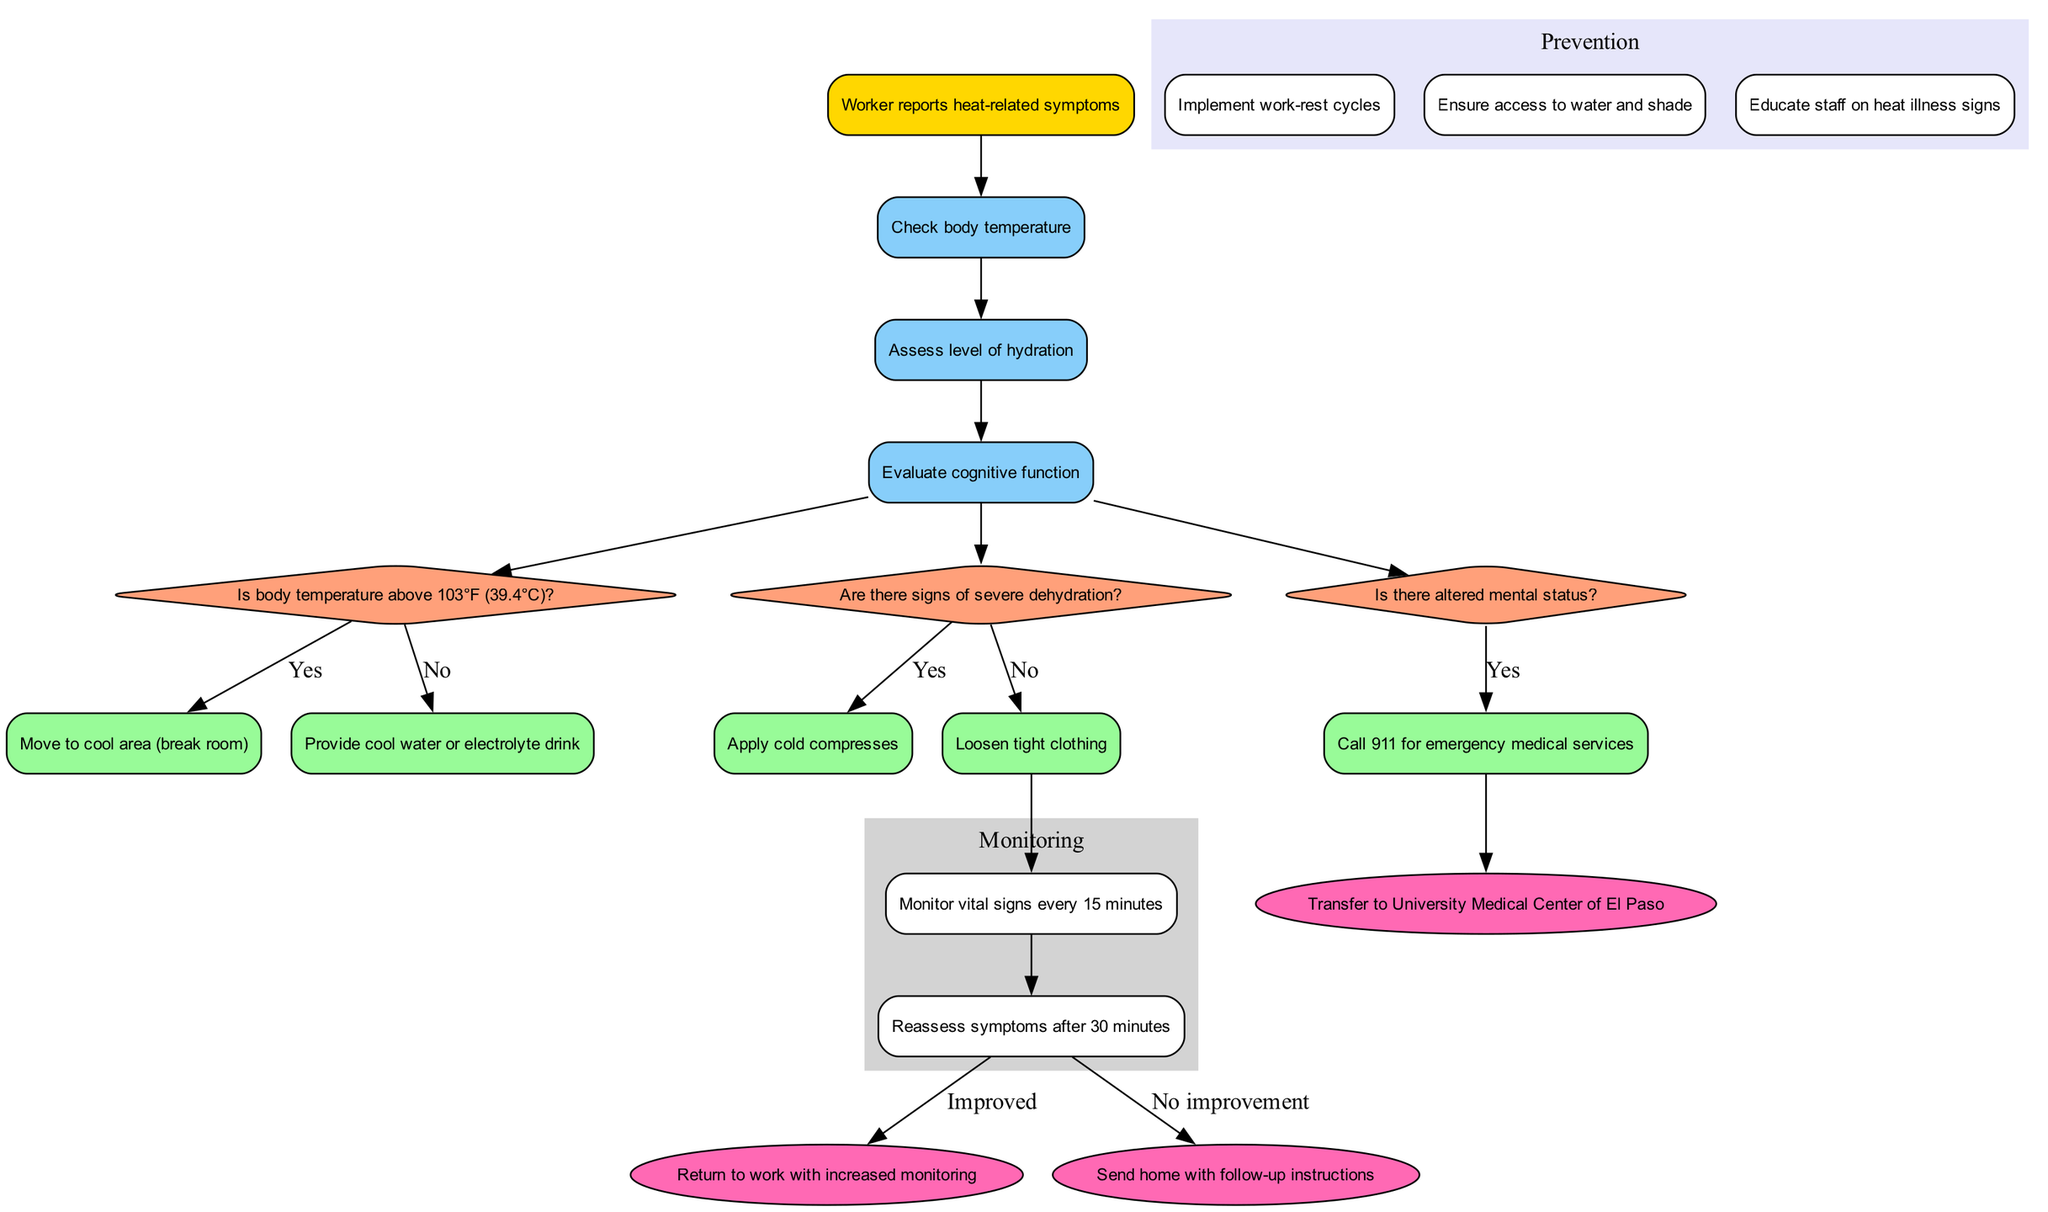What is the starting point of the clinical pathway? The starting point is indicated in the diagram as "Worker reports heat-related symptoms." This is the first node from which all assessment and decision-making steps are derived.
Answer: Worker reports heat-related symptoms How many assessment nodes are there? The diagram lists three assessment nodes: "Check body temperature," "Assess level of hydration," and "Evaluate cognitive function." Therefore, the total count can be directly gathered from this segment of the diagram.
Answer: 3 What action is taken if there are signs of severe dehydration? According to the diagram, if there are signs of severe dehydration, the action taken is to "Provide cool water or electrolyte drink." This action directly follows the relevant decision point regarding dehydration.
Answer: Provide cool water or electrolyte drink What happens if the body temperature is above 103°F? The diagram indicates that if the body temperature is above 103°F, the action is to "Move to cool area (break room)." This response is clearly linked to the corresponding decision point about body temperature.
Answer: Move to cool area (break room) What are the endpoints of the clinical pathway? The diagram outlines three endpoints, categorized as outcomes of the pathway: "Return to work with increased monitoring," "Send home with follow-up instructions," and "Transfer to University Medical Center of El Paso." This information can be found in the final section of the diagram.
Answer: Return to work with increased monitoring, Send home with follow-up instructions, Transfer to University Medical Center of El Paso If altered mental status is present, what is the next action? According to the diagram, if altered mental status is present, the action taken is to "Call 911 for emergency medical services." This step is clearly delineated in response to the relevant decision point regarding mental status.
Answer: Call 911 for emergency medical services What is the purpose of the monitoring steps? The monitoring steps serve to "Monitor vital signs every 15 minutes" and "Reassess symptoms after 30 minutes," indicating a structured approach to ensure the worker's safety and health. This ensures ongoing evaluation post-initial intervention.
Answer: Monitor vital signs every 15 minutes, Reassess symptoms after 30 minutes What preventive measures are outlined in the diagram? The preventive measures listed in the diagram include three key strategies: "Implement work-rest cycles," "Ensure access to water and shade," and "Educate staff on heat illness signs." This shows a proactive approach to managing heat-related risks.
Answer: Implement work-rest cycles, Ensure access to water and shade, Educate staff on heat illness signs 